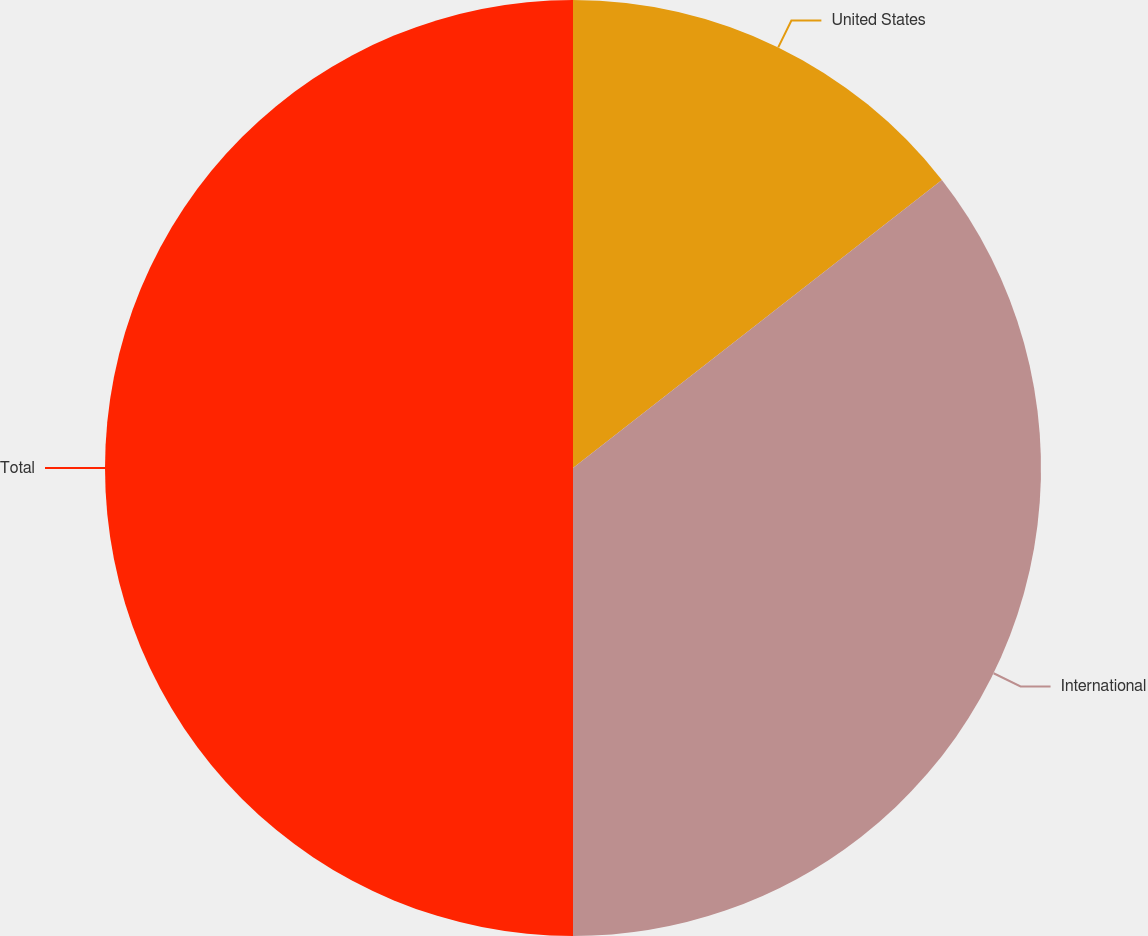<chart> <loc_0><loc_0><loc_500><loc_500><pie_chart><fcel>United States<fcel>International<fcel>Total<nl><fcel>14.45%<fcel>35.55%<fcel>50.0%<nl></chart> 